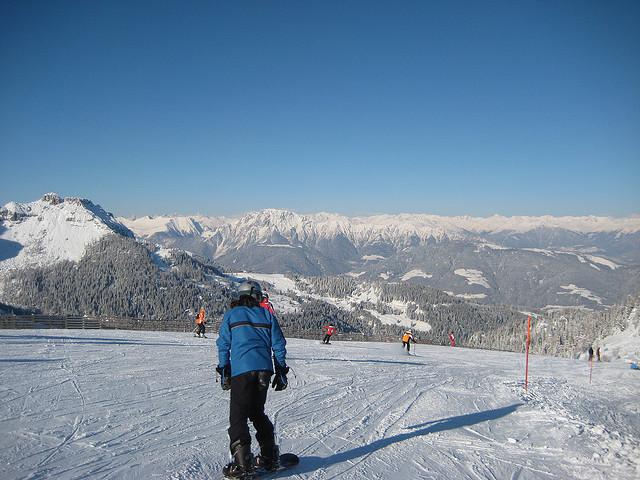Is the snow deep?
Be succinct. No. What terrain is this?
Short answer required. Mountains. Does this look like a difficult slope to ski?
Quick response, please. No. Are there mountains in the background?
Keep it brief. Yes. 